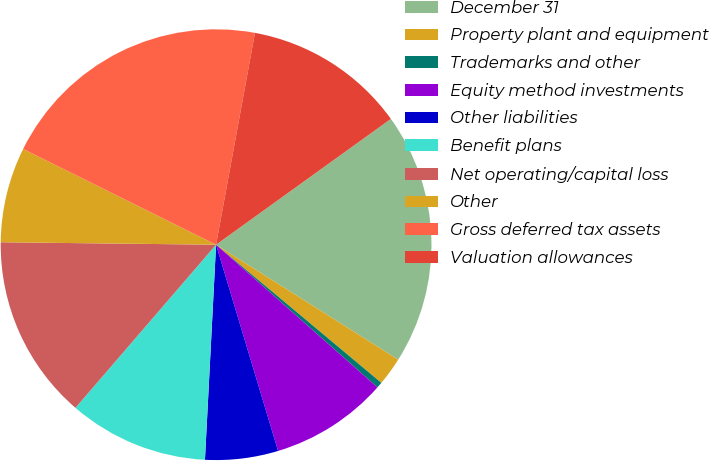Convert chart to OTSL. <chart><loc_0><loc_0><loc_500><loc_500><pie_chart><fcel>December 31<fcel>Property plant and equipment<fcel>Trademarks and other<fcel>Equity method investments<fcel>Other liabilities<fcel>Benefit plans<fcel>Net operating/capital loss<fcel>Other<fcel>Gross deferred tax assets<fcel>Valuation allowances<nl><fcel>18.89%<fcel>2.12%<fcel>0.44%<fcel>8.83%<fcel>5.47%<fcel>10.5%<fcel>13.86%<fcel>7.15%<fcel>20.56%<fcel>12.18%<nl></chart> 